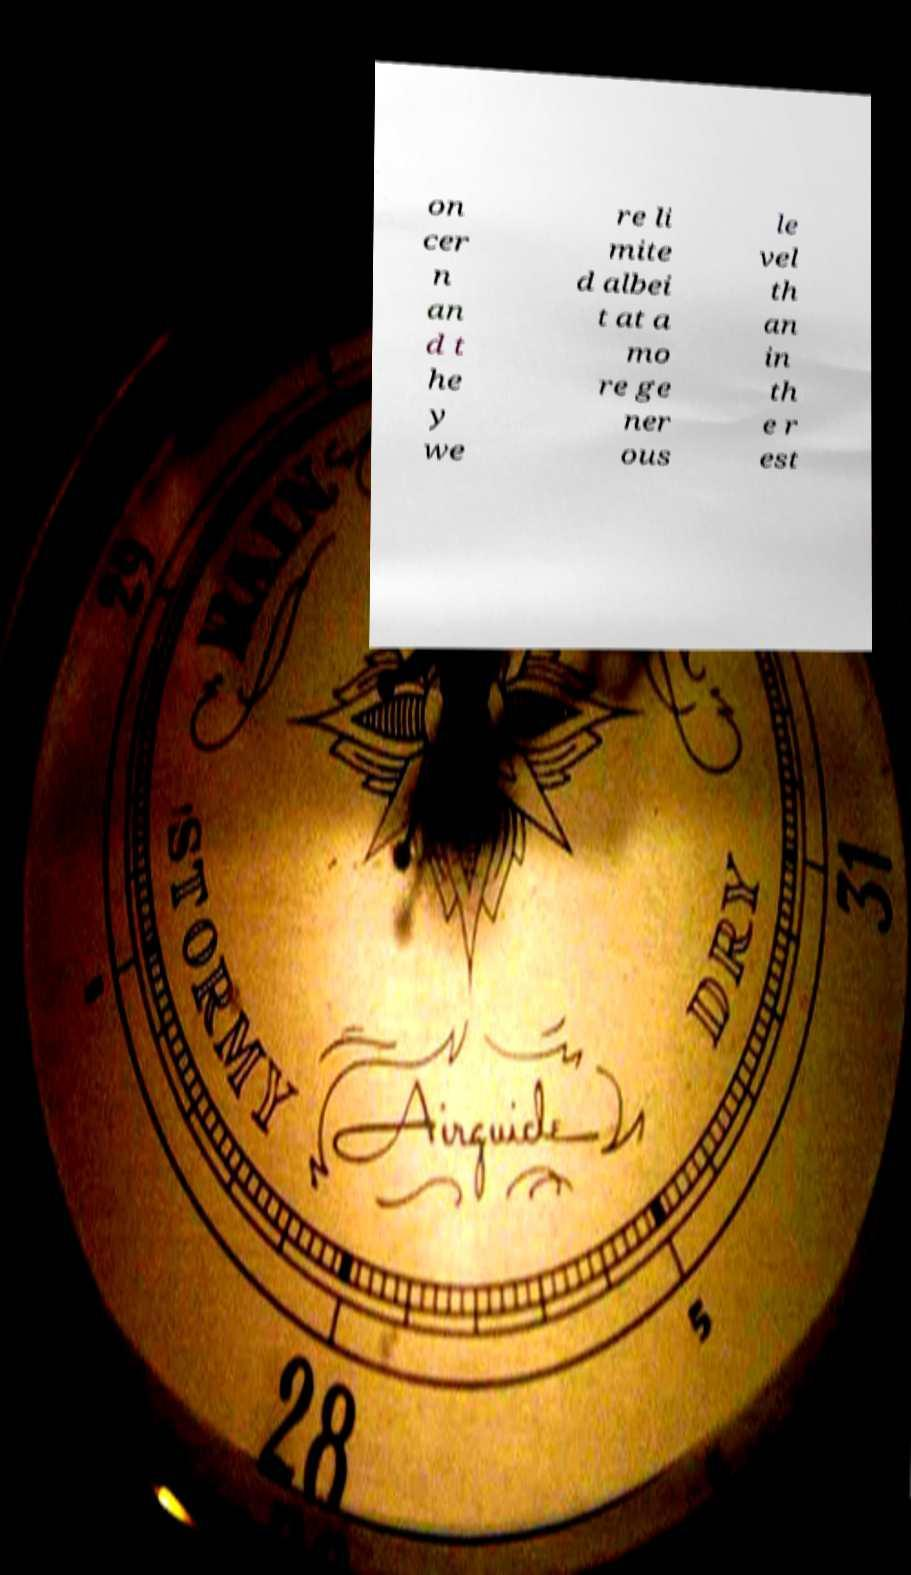What messages or text are displayed in this image? I need them in a readable, typed format. on cer n an d t he y we re li mite d albei t at a mo re ge ner ous le vel th an in th e r est 